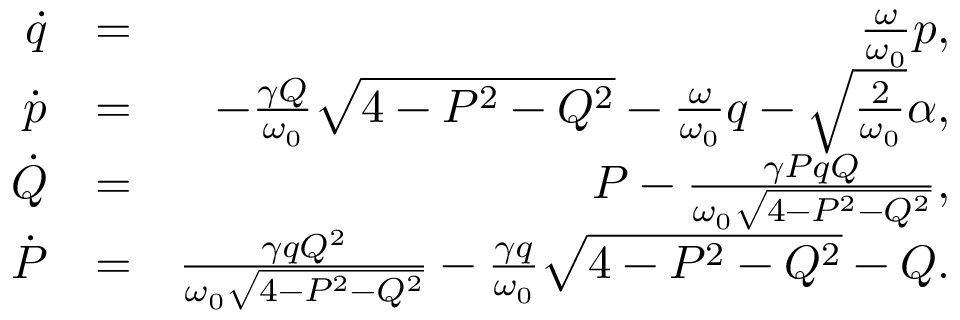<formula> <loc_0><loc_0><loc_500><loc_500>\begin{array} { r l r } { \dot { q } } & { = } & { \frac { \omega } { \omega _ { 0 } } p , } \\ { \dot { p } } & { = } & { - \frac { \gamma Q } { \omega _ { 0 } } \sqrt { 4 - P ^ { 2 } - Q ^ { 2 } } - \frac { \omega } { \omega _ { 0 } } q - \sqrt { \frac { 2 } { \omega _ { 0 } } } \alpha , } \\ { \dot { Q } } & { = } & { P - \frac { \gamma P q Q } { \omega _ { 0 } \sqrt { 4 - P ^ { 2 } - Q ^ { 2 } } } , } \\ { \dot { P } } & { = } & { \frac { \gamma q Q ^ { 2 } } { \omega _ { 0 } \sqrt { 4 - P ^ { 2 } - Q ^ { 2 } } } - \frac { \gamma q } { \omega _ { 0 } } \sqrt { 4 - P ^ { 2 } - Q ^ { 2 } } - Q . } \end{array}</formula> 